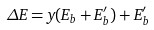<formula> <loc_0><loc_0><loc_500><loc_500>\Delta E = y ( E _ { b } + E _ { b } ^ { \prime } ) + E _ { b } ^ { \prime }</formula> 